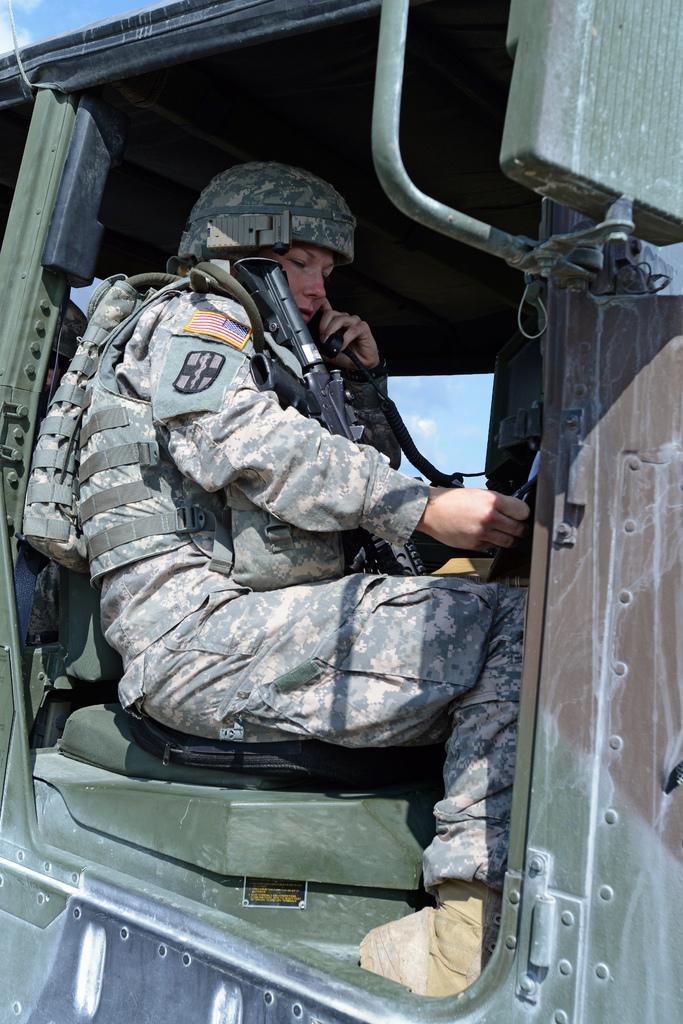Please provide a concise description of this image. In this image I can see in the middle a person is sitting in a vehicle. This person is wearing an army dress and also holding a weapon. 